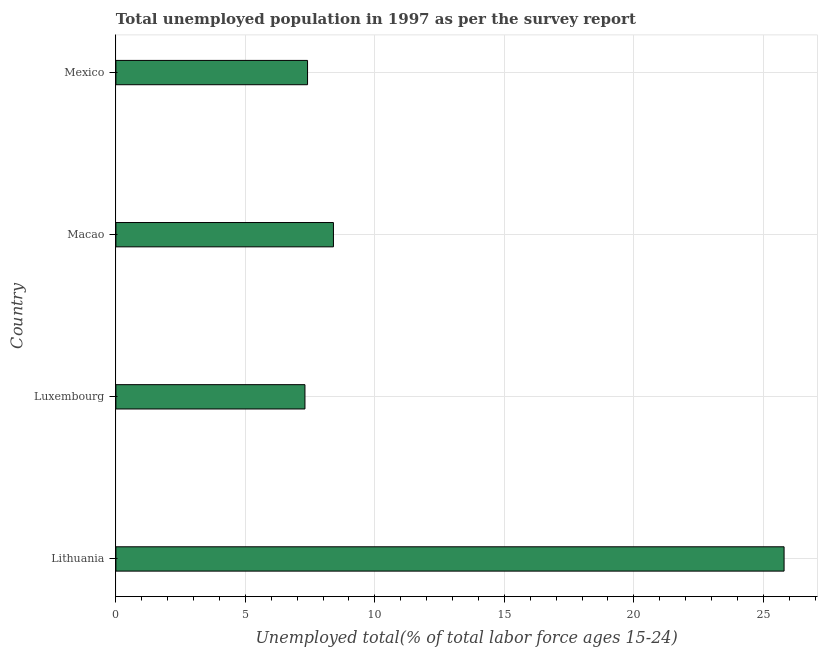Does the graph contain any zero values?
Offer a terse response. No. What is the title of the graph?
Provide a short and direct response. Total unemployed population in 1997 as per the survey report. What is the label or title of the X-axis?
Offer a terse response. Unemployed total(% of total labor force ages 15-24). What is the label or title of the Y-axis?
Ensure brevity in your answer.  Country. What is the unemployed youth in Lithuania?
Provide a short and direct response. 25.8. Across all countries, what is the maximum unemployed youth?
Ensure brevity in your answer.  25.8. Across all countries, what is the minimum unemployed youth?
Provide a short and direct response. 7.3. In which country was the unemployed youth maximum?
Make the answer very short. Lithuania. In which country was the unemployed youth minimum?
Provide a short and direct response. Luxembourg. What is the sum of the unemployed youth?
Keep it short and to the point. 48.9. What is the average unemployed youth per country?
Offer a very short reply. 12.22. What is the median unemployed youth?
Make the answer very short. 7.9. What is the ratio of the unemployed youth in Lithuania to that in Macao?
Provide a short and direct response. 3.07. In how many countries, is the unemployed youth greater than the average unemployed youth taken over all countries?
Your response must be concise. 1. How many countries are there in the graph?
Your answer should be very brief. 4. Are the values on the major ticks of X-axis written in scientific E-notation?
Your answer should be compact. No. What is the Unemployed total(% of total labor force ages 15-24) of Lithuania?
Your response must be concise. 25.8. What is the Unemployed total(% of total labor force ages 15-24) in Luxembourg?
Keep it short and to the point. 7.3. What is the Unemployed total(% of total labor force ages 15-24) in Macao?
Offer a very short reply. 8.4. What is the Unemployed total(% of total labor force ages 15-24) in Mexico?
Your answer should be compact. 7.4. What is the difference between the Unemployed total(% of total labor force ages 15-24) in Lithuania and Luxembourg?
Give a very brief answer. 18.5. What is the difference between the Unemployed total(% of total labor force ages 15-24) in Luxembourg and Macao?
Give a very brief answer. -1.1. What is the difference between the Unemployed total(% of total labor force ages 15-24) in Luxembourg and Mexico?
Provide a short and direct response. -0.1. What is the difference between the Unemployed total(% of total labor force ages 15-24) in Macao and Mexico?
Offer a very short reply. 1. What is the ratio of the Unemployed total(% of total labor force ages 15-24) in Lithuania to that in Luxembourg?
Your response must be concise. 3.53. What is the ratio of the Unemployed total(% of total labor force ages 15-24) in Lithuania to that in Macao?
Give a very brief answer. 3.07. What is the ratio of the Unemployed total(% of total labor force ages 15-24) in Lithuania to that in Mexico?
Offer a very short reply. 3.49. What is the ratio of the Unemployed total(% of total labor force ages 15-24) in Luxembourg to that in Macao?
Keep it short and to the point. 0.87. What is the ratio of the Unemployed total(% of total labor force ages 15-24) in Macao to that in Mexico?
Provide a short and direct response. 1.14. 